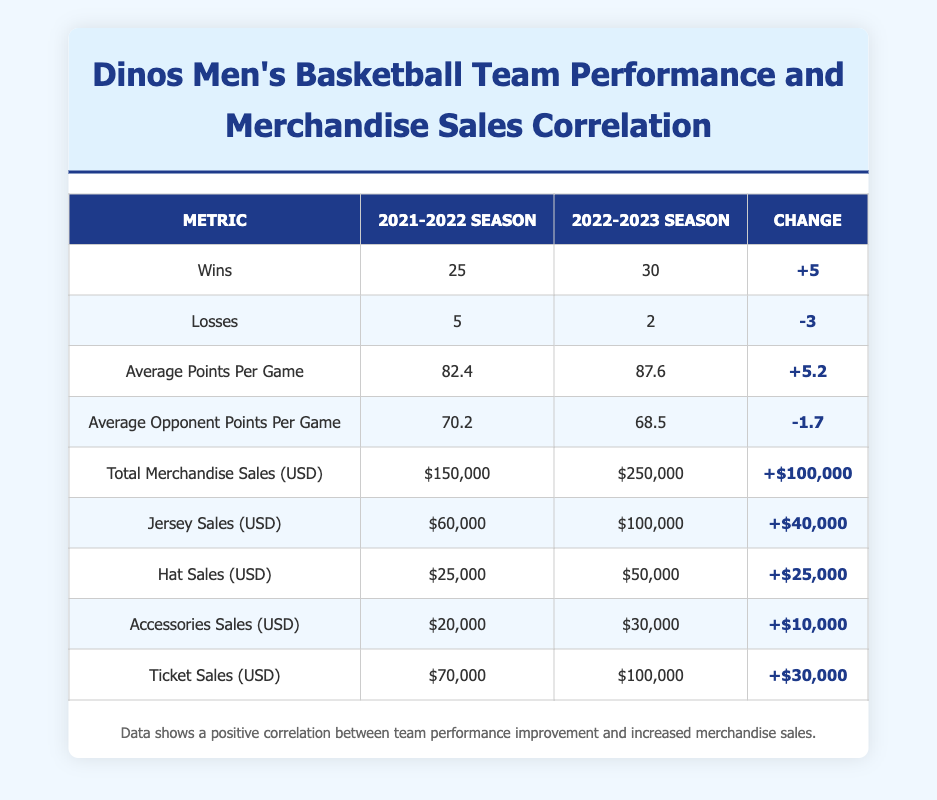What was the total merchandise sales for the 2021-2022 season? Looking at the table, the total merchandise sales for the 2021-2022 season is located under the "Total Merchandise Sales (USD)" row, which shows $150,000.
Answer: $150,000 How many wins did the Dinos have in the 2022-2023 season? Referring to the "Wins" row under the 2022-2023 season, the value presented is 30.
Answer: 30 What is the change in ticket sales from the 2021-2022 season to the 2022-2023 season? The difference in ticket sales can be calculated by subtracting the 2021-2022 ticket sales ($70,000) from the 2022-2023 ticket sales ($100,000). Thus, $100,000 - $70,000 = $30,000.
Answer: $30,000 Did the average points per game increase from the 2021-2022 season to the 2022-2023 season? By comparing the "Average Points Per Game" values, the 2021-2022 season had an average of 82.4 points, while the 2022-2023 season increased to 87.6 points. Since 87.6 is greater than 82.4, the statement is true.
Answer: Yes Which season saw a larger increase in total merchandise sales, and by how much? The total merchandise sales for the 2022-2023 season is $250,000, and for the 2021-2022 season, it is $150,000. The increase is calculated as $250,000 - $150,000 = $100,000. The increase in sales was therefore solely seen in the 2022-2023 season and amounts to $100,000.
Answer: 2022-2023 season, $100,000 What was the average sales for jersey sales during the 2022-2023 season? The table states that jersey sales for the 2022-2023 season amounted to $100,000. This value is directly referenced under "Jersey Sales (USD)" for that season.
Answer: $100,000 Did the Dinos' losses decrease from the 2021-2022 season to the 2022-2023 season? The losses for the 2021-2022 season were 5, while for the 2022-2023 season, they were 2. Since 2 is less than 5, the losses indeed decreased.
Answer: Yes What was the total increase in accessory sales from the 2021-2022 season to the 2022-2023 season? The accessory sales for the 2021-2022 season were $20,000, and for the 2022-2023 season, they were $30,000. Therefore, the increase in accessory sales can be calculated as $30,000 - $20,000, which equals $10,000.
Answer: $10,000 